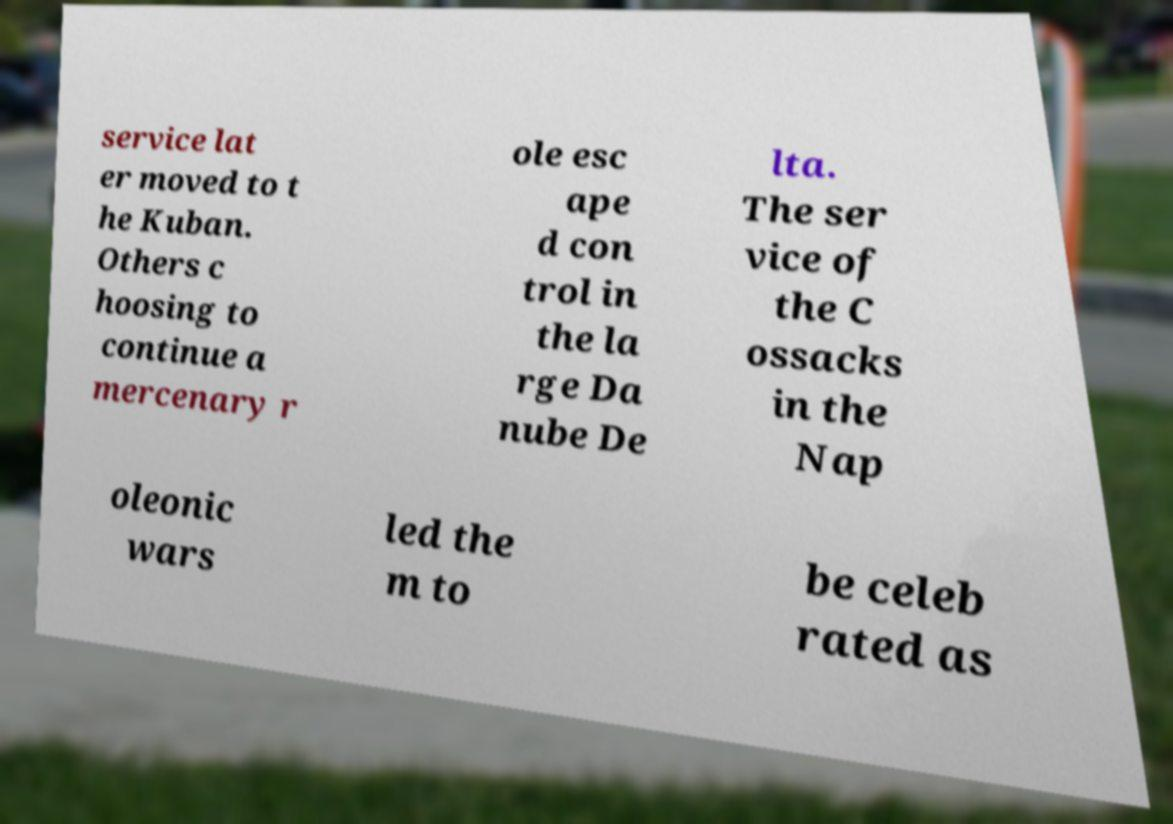I need the written content from this picture converted into text. Can you do that? service lat er moved to t he Kuban. Others c hoosing to continue a mercenary r ole esc ape d con trol in the la rge Da nube De lta. The ser vice of the C ossacks in the Nap oleonic wars led the m to be celeb rated as 